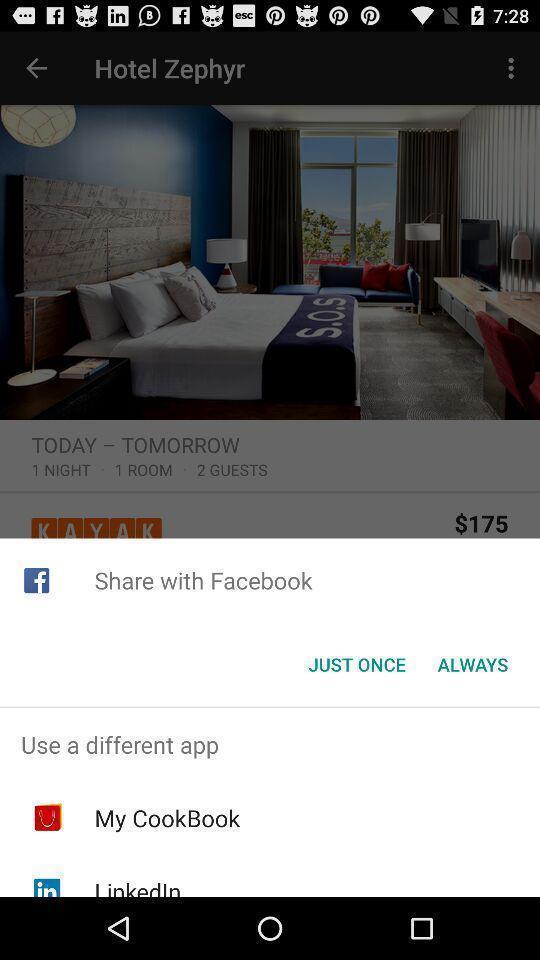Provide a textual representation of this image. Share page to select through which app to complete action. 